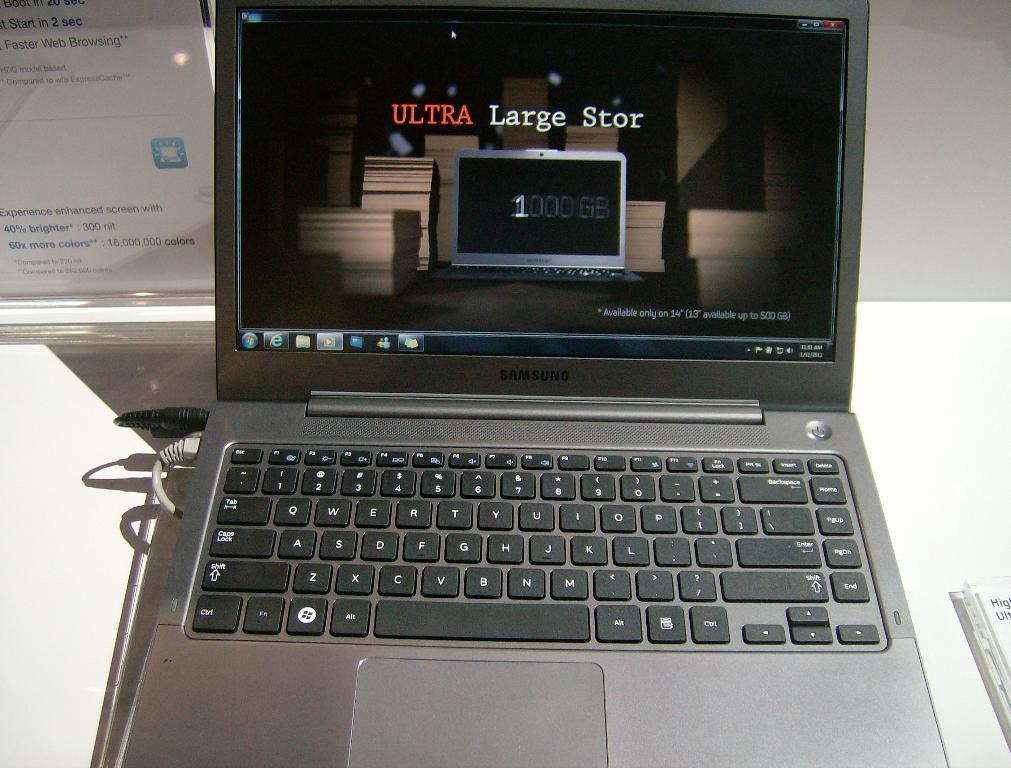<image>
Share a concise interpretation of the image provided. a black samsung laptop with a screen that says 'ultra large stor' 